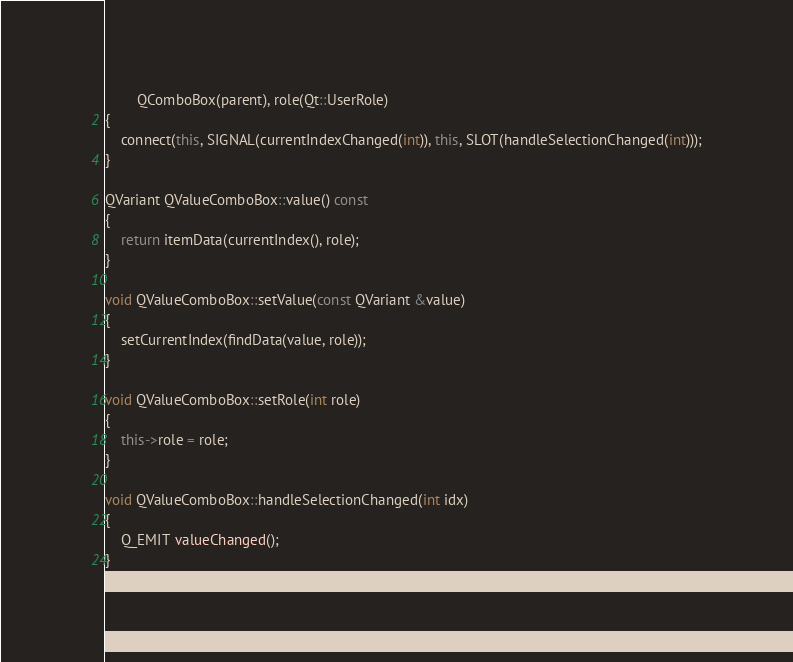Convert code to text. <code><loc_0><loc_0><loc_500><loc_500><_C++_>        QComboBox(parent), role(Qt::UserRole)
{
    connect(this, SIGNAL(currentIndexChanged(int)), this, SLOT(handleSelectionChanged(int)));
}

QVariant QValueComboBox::value() const
{
    return itemData(currentIndex(), role);
}

void QValueComboBox::setValue(const QVariant &value)
{
    setCurrentIndex(findData(value, role));
}

void QValueComboBox::setRole(int role)
{
    this->role = role;
}

void QValueComboBox::handleSelectionChanged(int idx)
{
    Q_EMIT valueChanged();
}
</code> 